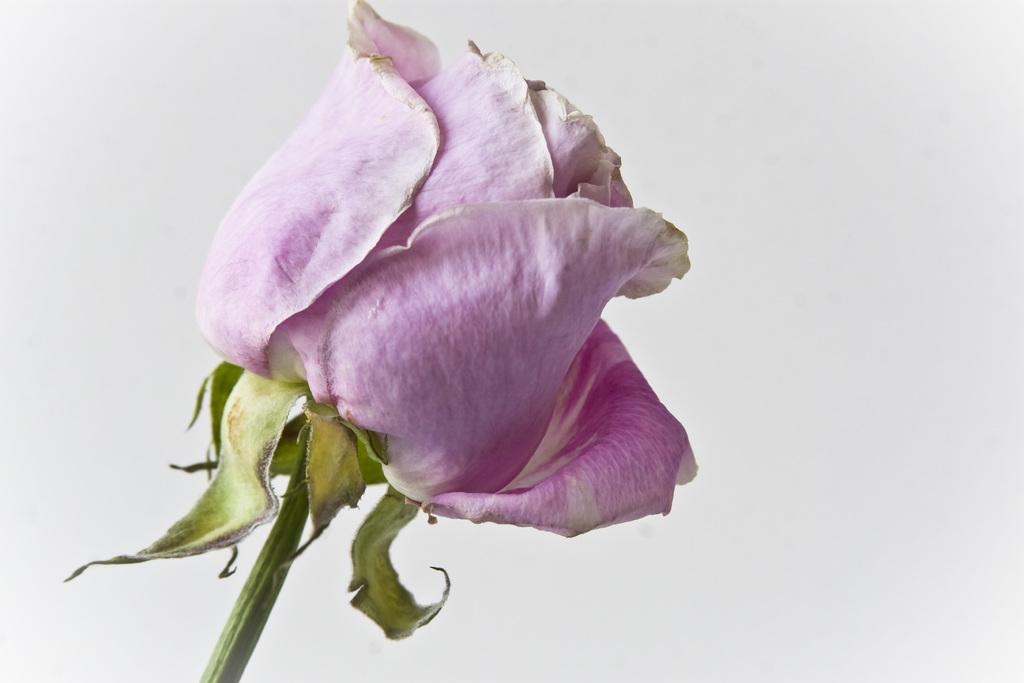Could you give a brief overview of what you see in this image? In this image I can see a rose with pink color and in the background I can see white color and I can see stem with green color. 